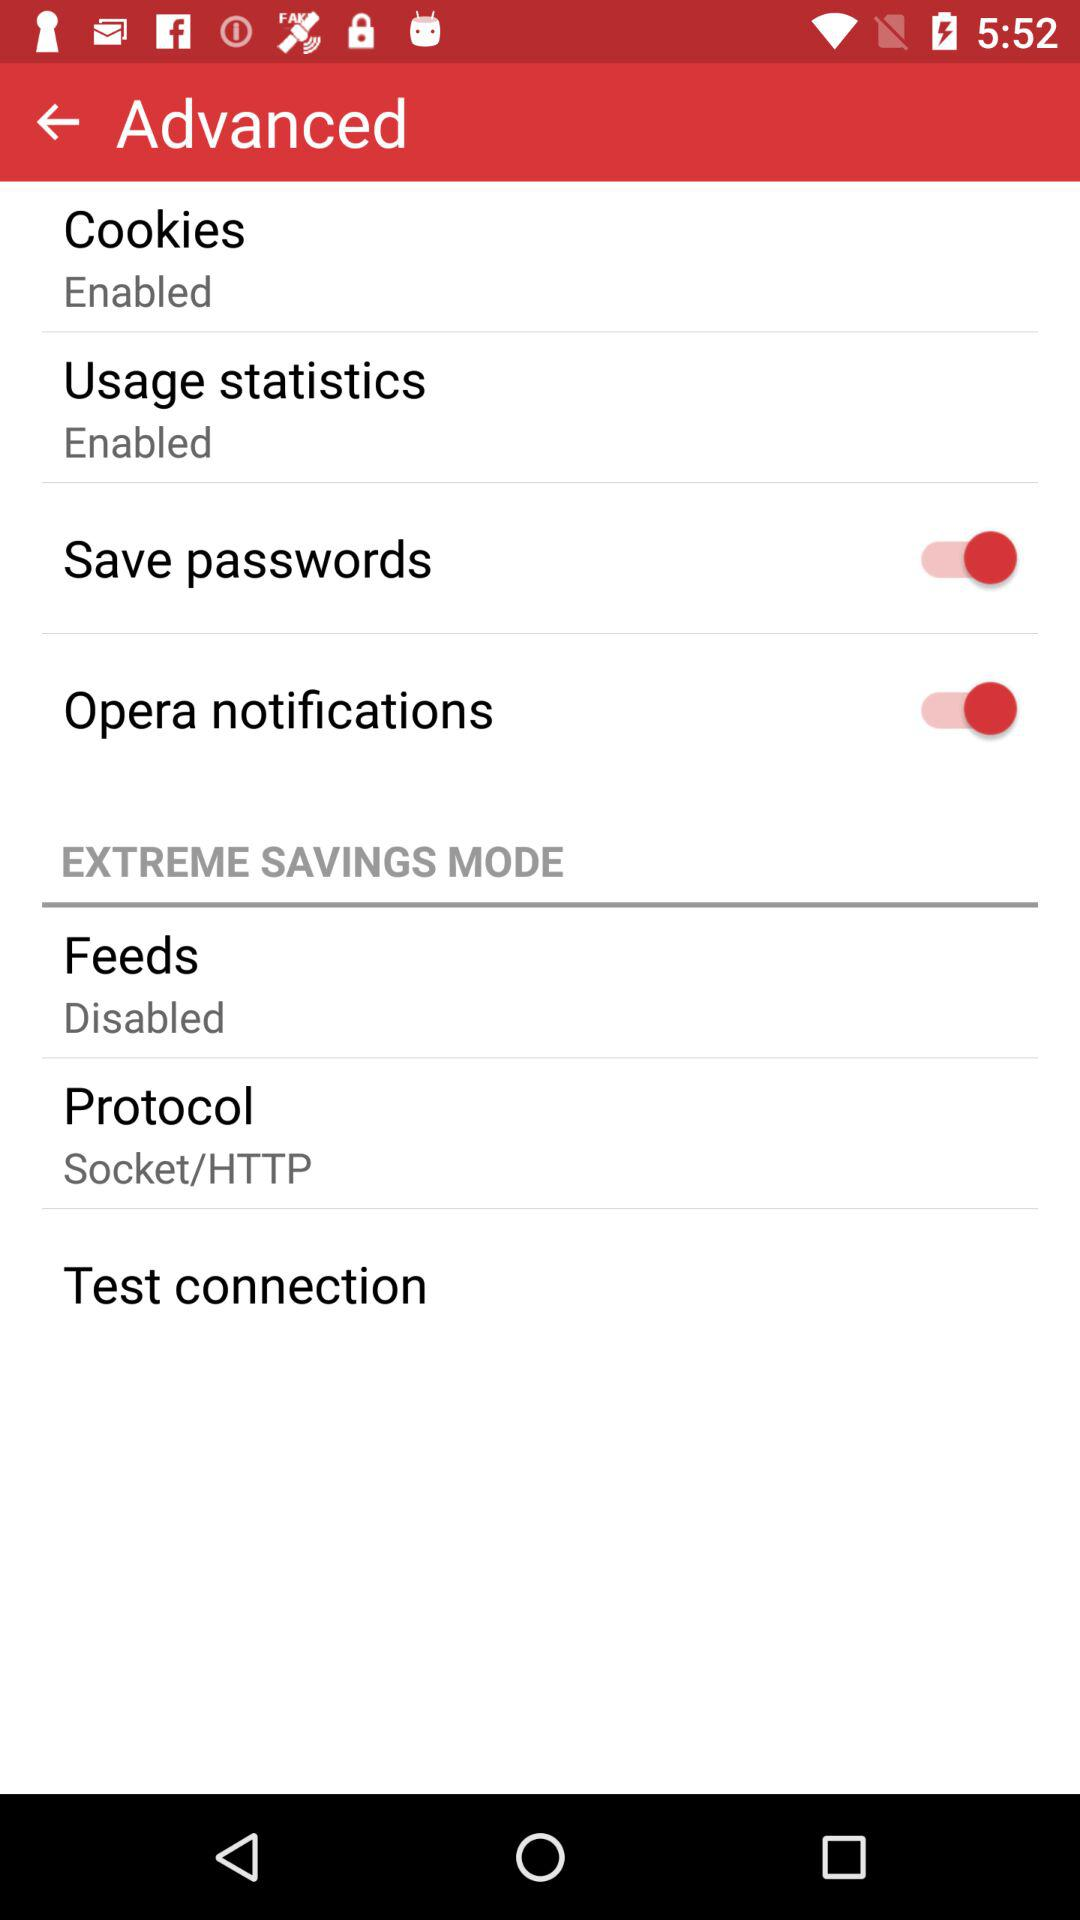What is the status of "Save passwords"? The status of "Save passwords" is "on". 